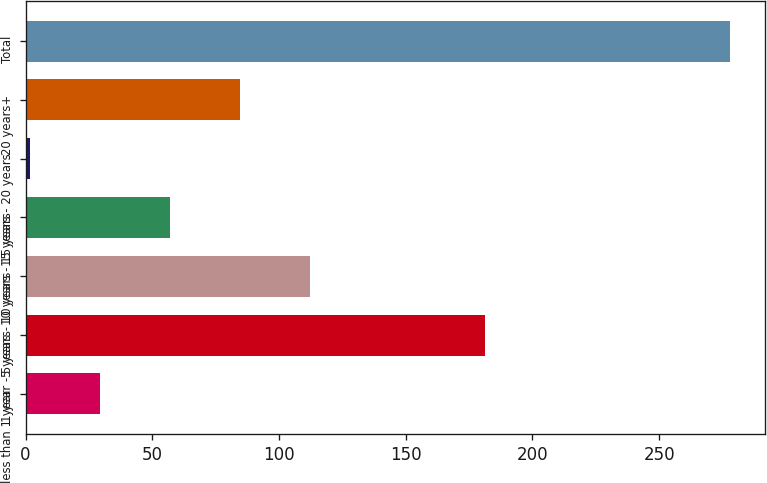Convert chart. <chart><loc_0><loc_0><loc_500><loc_500><bar_chart><fcel>less than 1 year<fcel>1 year - 5 years<fcel>5 years - 10 years<fcel>10 years - 15 years<fcel>15 years - 20 years<fcel>20 years+<fcel>Total<nl><fcel>29.22<fcel>181.2<fcel>112.08<fcel>56.84<fcel>1.6<fcel>84.46<fcel>277.8<nl></chart> 